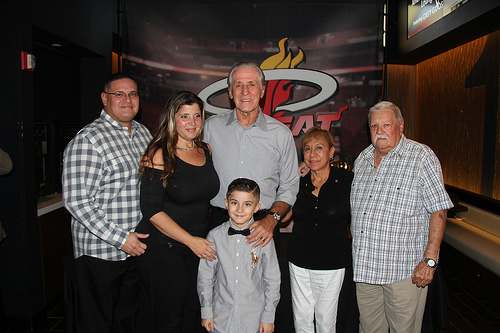<image>
Is the child to the right of the man? No. The child is not to the right of the man. The horizontal positioning shows a different relationship. 